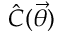<formula> <loc_0><loc_0><loc_500><loc_500>\hat { C } ( \vec { \theta } )</formula> 